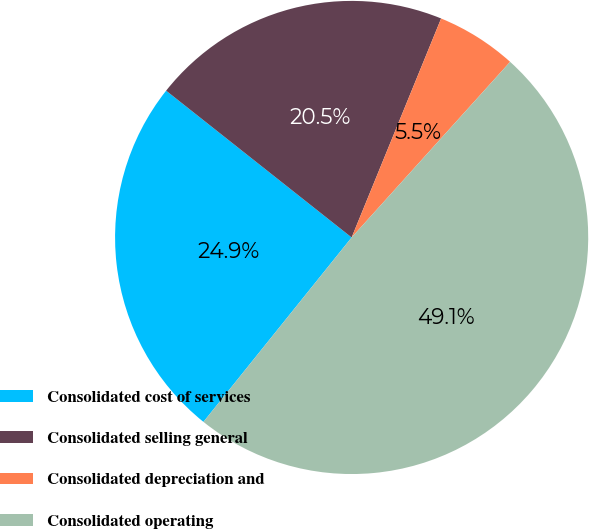<chart> <loc_0><loc_0><loc_500><loc_500><pie_chart><fcel>Consolidated cost of services<fcel>Consolidated selling general<fcel>Consolidated depreciation and<fcel>Consolidated operating<nl><fcel>24.88%<fcel>20.52%<fcel>5.51%<fcel>49.09%<nl></chart> 